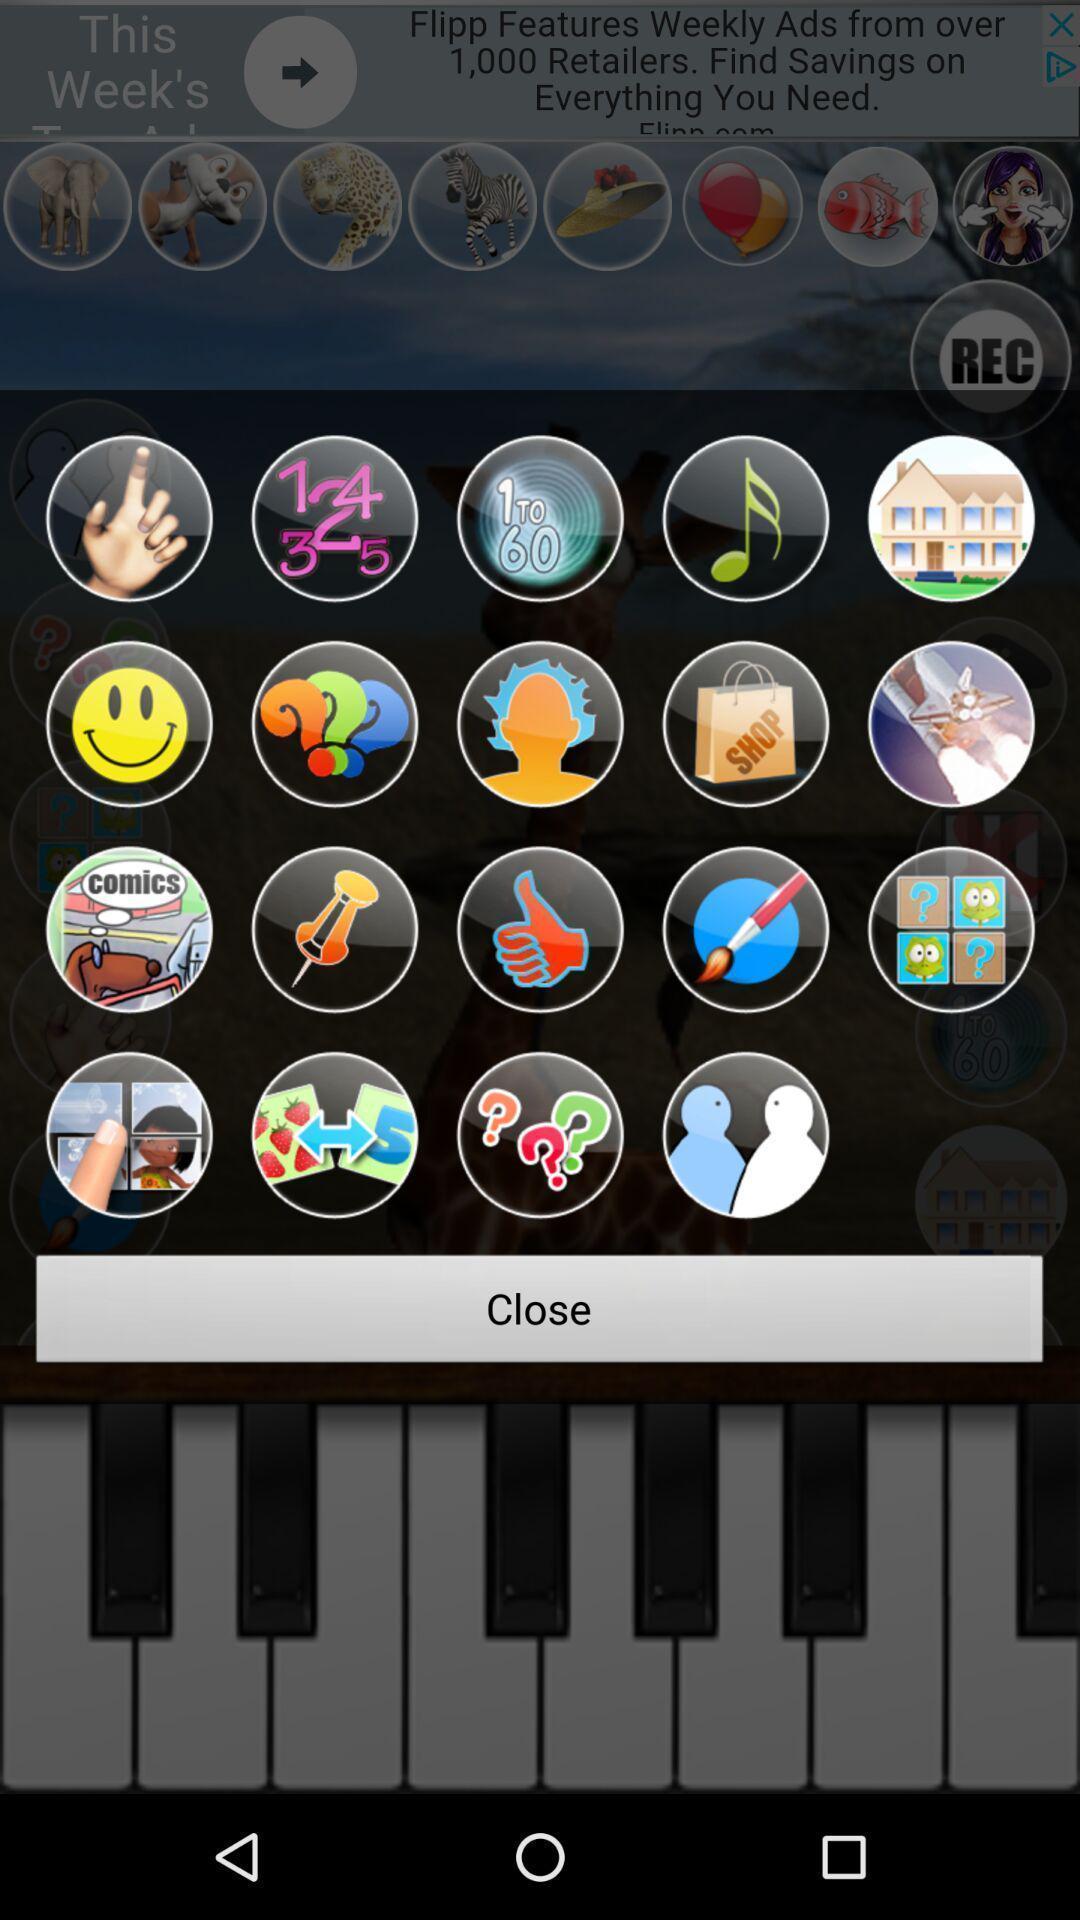What is the overall content of this screenshot? Pop-up with different stickers to use. 